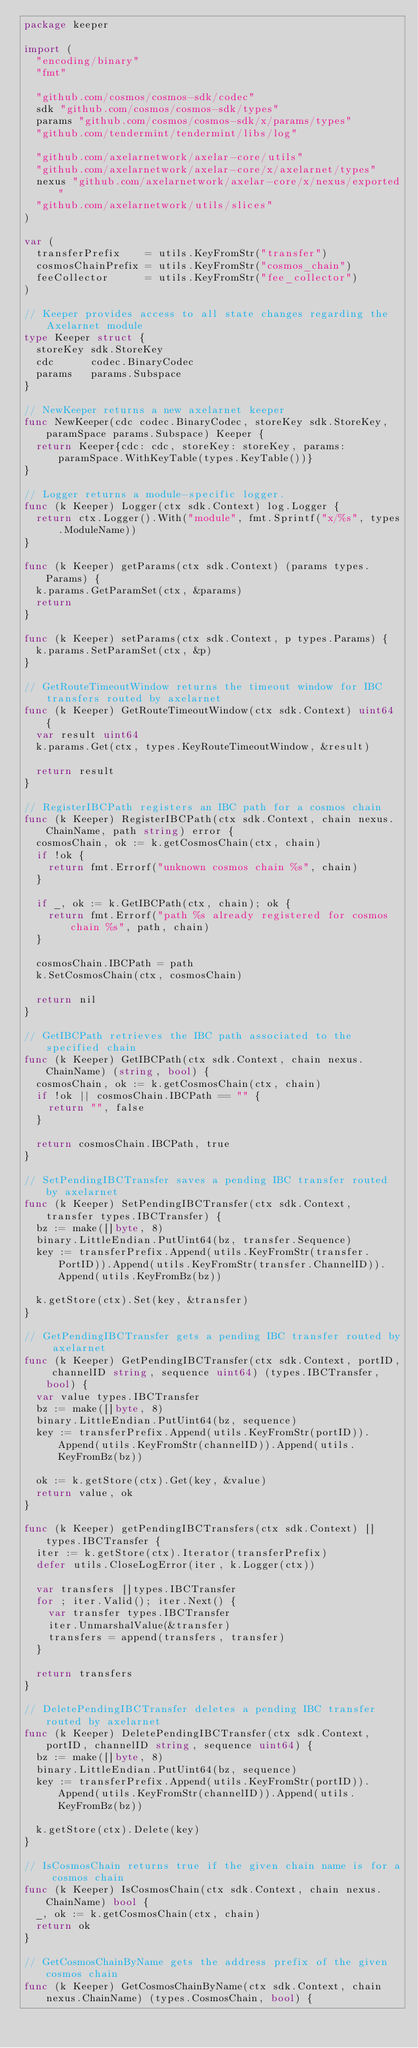<code> <loc_0><loc_0><loc_500><loc_500><_Go_>package keeper

import (
	"encoding/binary"
	"fmt"

	"github.com/cosmos/cosmos-sdk/codec"
	sdk "github.com/cosmos/cosmos-sdk/types"
	params "github.com/cosmos/cosmos-sdk/x/params/types"
	"github.com/tendermint/tendermint/libs/log"

	"github.com/axelarnetwork/axelar-core/utils"
	"github.com/axelarnetwork/axelar-core/x/axelarnet/types"
	nexus "github.com/axelarnetwork/axelar-core/x/nexus/exported"
	"github.com/axelarnetwork/utils/slices"
)

var (
	transferPrefix    = utils.KeyFromStr("transfer")
	cosmosChainPrefix = utils.KeyFromStr("cosmos_chain")
	feeCollector      = utils.KeyFromStr("fee_collector")
)

// Keeper provides access to all state changes regarding the Axelarnet module
type Keeper struct {
	storeKey sdk.StoreKey
	cdc      codec.BinaryCodec
	params   params.Subspace
}

// NewKeeper returns a new axelarnet keeper
func NewKeeper(cdc codec.BinaryCodec, storeKey sdk.StoreKey, paramSpace params.Subspace) Keeper {
	return Keeper{cdc: cdc, storeKey: storeKey, params: paramSpace.WithKeyTable(types.KeyTable())}
}

// Logger returns a module-specific logger.
func (k Keeper) Logger(ctx sdk.Context) log.Logger {
	return ctx.Logger().With("module", fmt.Sprintf("x/%s", types.ModuleName))
}

func (k Keeper) getParams(ctx sdk.Context) (params types.Params) {
	k.params.GetParamSet(ctx, &params)
	return
}

func (k Keeper) setParams(ctx sdk.Context, p types.Params) {
	k.params.SetParamSet(ctx, &p)
}

// GetRouteTimeoutWindow returns the timeout window for IBC transfers routed by axelarnet
func (k Keeper) GetRouteTimeoutWindow(ctx sdk.Context) uint64 {
	var result uint64
	k.params.Get(ctx, types.KeyRouteTimeoutWindow, &result)

	return result
}

// RegisterIBCPath registers an IBC path for a cosmos chain
func (k Keeper) RegisterIBCPath(ctx sdk.Context, chain nexus.ChainName, path string) error {
	cosmosChain, ok := k.getCosmosChain(ctx, chain)
	if !ok {
		return fmt.Errorf("unknown cosmos chain %s", chain)
	}

	if _, ok := k.GetIBCPath(ctx, chain); ok {
		return fmt.Errorf("path %s already registered for cosmos chain %s", path, chain)
	}

	cosmosChain.IBCPath = path
	k.SetCosmosChain(ctx, cosmosChain)

	return nil
}

// GetIBCPath retrieves the IBC path associated to the specified chain
func (k Keeper) GetIBCPath(ctx sdk.Context, chain nexus.ChainName) (string, bool) {
	cosmosChain, ok := k.getCosmosChain(ctx, chain)
	if !ok || cosmosChain.IBCPath == "" {
		return "", false
	}

	return cosmosChain.IBCPath, true
}

// SetPendingIBCTransfer saves a pending IBC transfer routed by axelarnet
func (k Keeper) SetPendingIBCTransfer(ctx sdk.Context, transfer types.IBCTransfer) {
	bz := make([]byte, 8)
	binary.LittleEndian.PutUint64(bz, transfer.Sequence)
	key := transferPrefix.Append(utils.KeyFromStr(transfer.PortID)).Append(utils.KeyFromStr(transfer.ChannelID)).Append(utils.KeyFromBz(bz))

	k.getStore(ctx).Set(key, &transfer)
}

// GetPendingIBCTransfer gets a pending IBC transfer routed by axelarnet
func (k Keeper) GetPendingIBCTransfer(ctx sdk.Context, portID, channelID string, sequence uint64) (types.IBCTransfer, bool) {
	var value types.IBCTransfer
	bz := make([]byte, 8)
	binary.LittleEndian.PutUint64(bz, sequence)
	key := transferPrefix.Append(utils.KeyFromStr(portID)).Append(utils.KeyFromStr(channelID)).Append(utils.KeyFromBz(bz))

	ok := k.getStore(ctx).Get(key, &value)
	return value, ok
}

func (k Keeper) getPendingIBCTransfers(ctx sdk.Context) []types.IBCTransfer {
	iter := k.getStore(ctx).Iterator(transferPrefix)
	defer utils.CloseLogError(iter, k.Logger(ctx))

	var transfers []types.IBCTransfer
	for ; iter.Valid(); iter.Next() {
		var transfer types.IBCTransfer
		iter.UnmarshalValue(&transfer)
		transfers = append(transfers, transfer)
	}

	return transfers
}

// DeletePendingIBCTransfer deletes a pending IBC transfer routed by axelarnet
func (k Keeper) DeletePendingIBCTransfer(ctx sdk.Context, portID, channelID string, sequence uint64) {
	bz := make([]byte, 8)
	binary.LittleEndian.PutUint64(bz, sequence)
	key := transferPrefix.Append(utils.KeyFromStr(portID)).Append(utils.KeyFromStr(channelID)).Append(utils.KeyFromBz(bz))

	k.getStore(ctx).Delete(key)
}

// IsCosmosChain returns true if the given chain name is for a cosmos chain
func (k Keeper) IsCosmosChain(ctx sdk.Context, chain nexus.ChainName) bool {
	_, ok := k.getCosmosChain(ctx, chain)
	return ok
}

// GetCosmosChainByName gets the address prefix of the given cosmos chain
func (k Keeper) GetCosmosChainByName(ctx sdk.Context, chain nexus.ChainName) (types.CosmosChain, bool) {</code> 